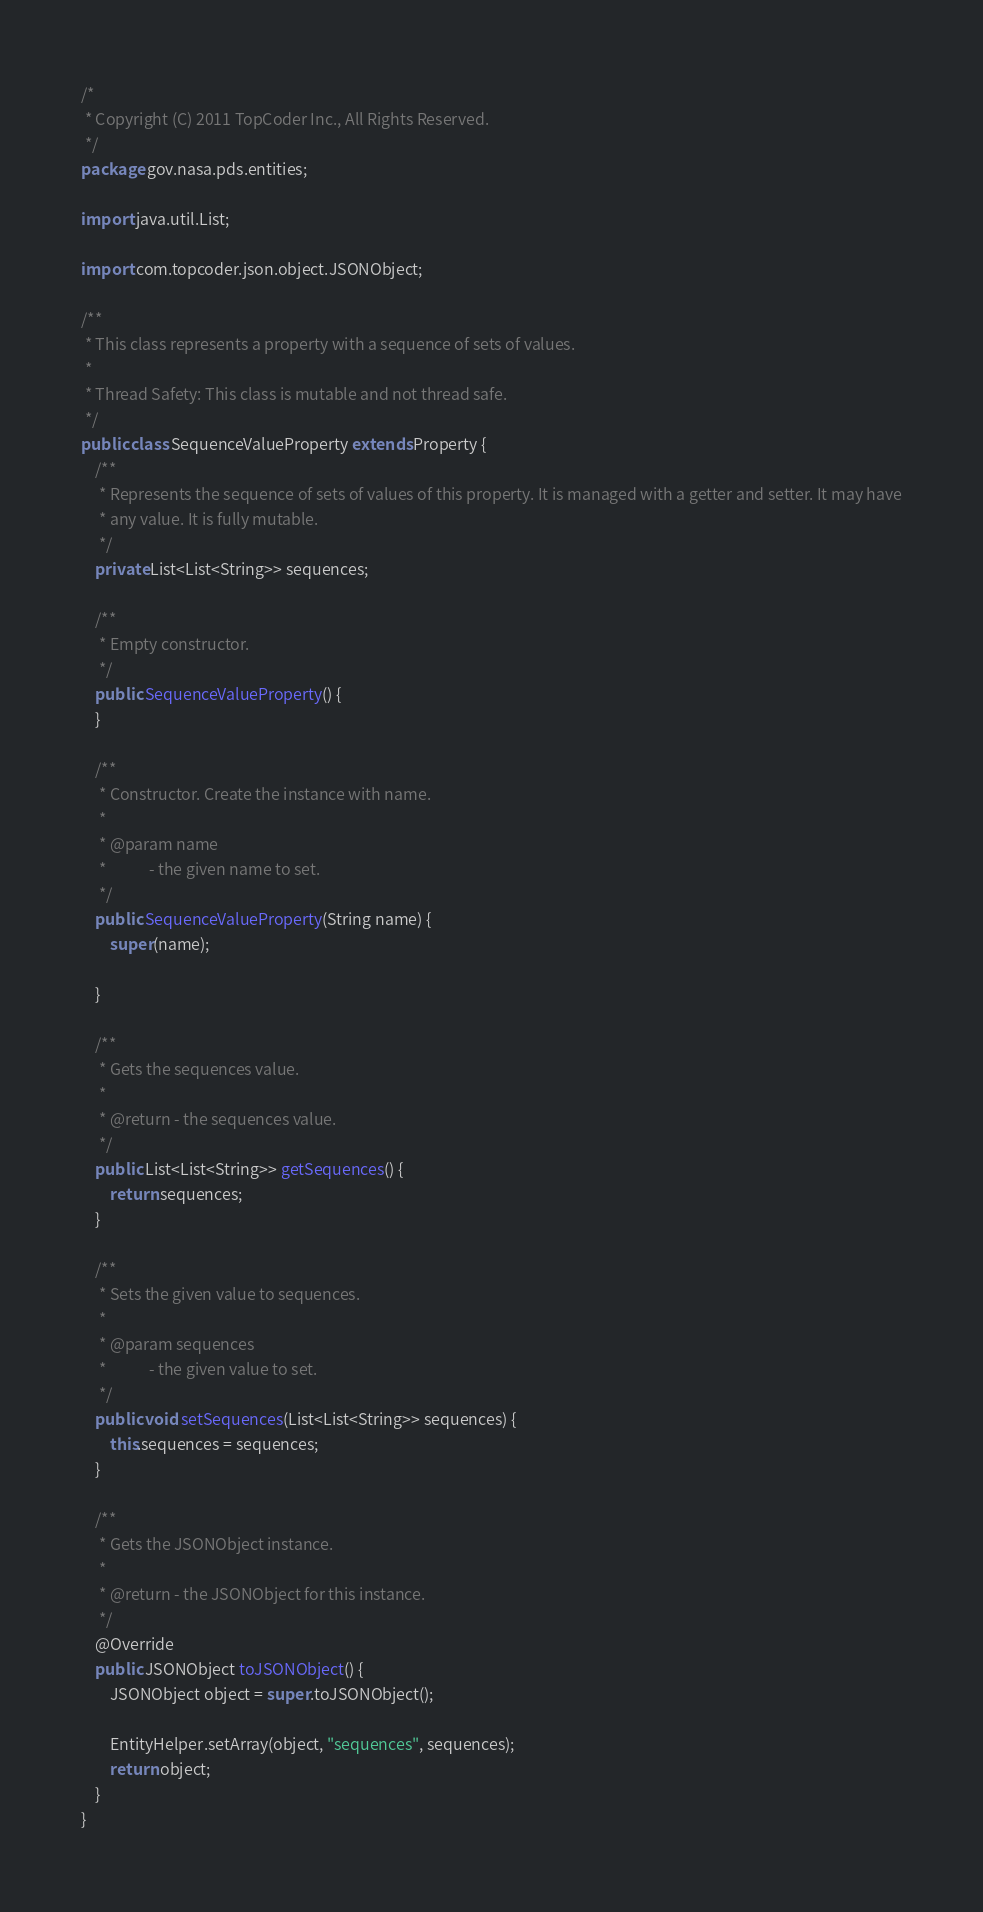<code> <loc_0><loc_0><loc_500><loc_500><_Java_>/*
 * Copyright (C) 2011 TopCoder Inc., All Rights Reserved.
 */
package gov.nasa.pds.entities;

import java.util.List;

import com.topcoder.json.object.JSONObject;

/**
 * This class represents a property with a sequence of sets of values.
 * 
 * Thread Safety: This class is mutable and not thread safe.
 */
public class SequenceValueProperty extends Property {
    /**
     * Represents the sequence of sets of values of this property. It is managed with a getter and setter. It may have
     * any value. It is fully mutable.
     */
    private List<List<String>> sequences;

    /**
     * Empty constructor.
     */
    public SequenceValueProperty() {
    }

    /**
     * Constructor. Create the instance with name.
     * 
     * @param name
     *            - the given name to set.
     */
    public SequenceValueProperty(String name) {
        super(name);

    }

    /**
     * Gets the sequences value.
     * 
     * @return - the sequences value.
     */
    public List<List<String>> getSequences() {
        return sequences;
    }

    /**
     * Sets the given value to sequences.
     * 
     * @param sequences
     *            - the given value to set.
     */
    public void setSequences(List<List<String>> sequences) {
        this.sequences = sequences;
    }

    /**
     * Gets the JSONObject instance.
     * 
     * @return - the JSONObject for this instance.
     */
    @Override
    public JSONObject toJSONObject() {
        JSONObject object = super.toJSONObject();

        EntityHelper.setArray(object, "sequences", sequences);
        return object;
    }
}
</code> 